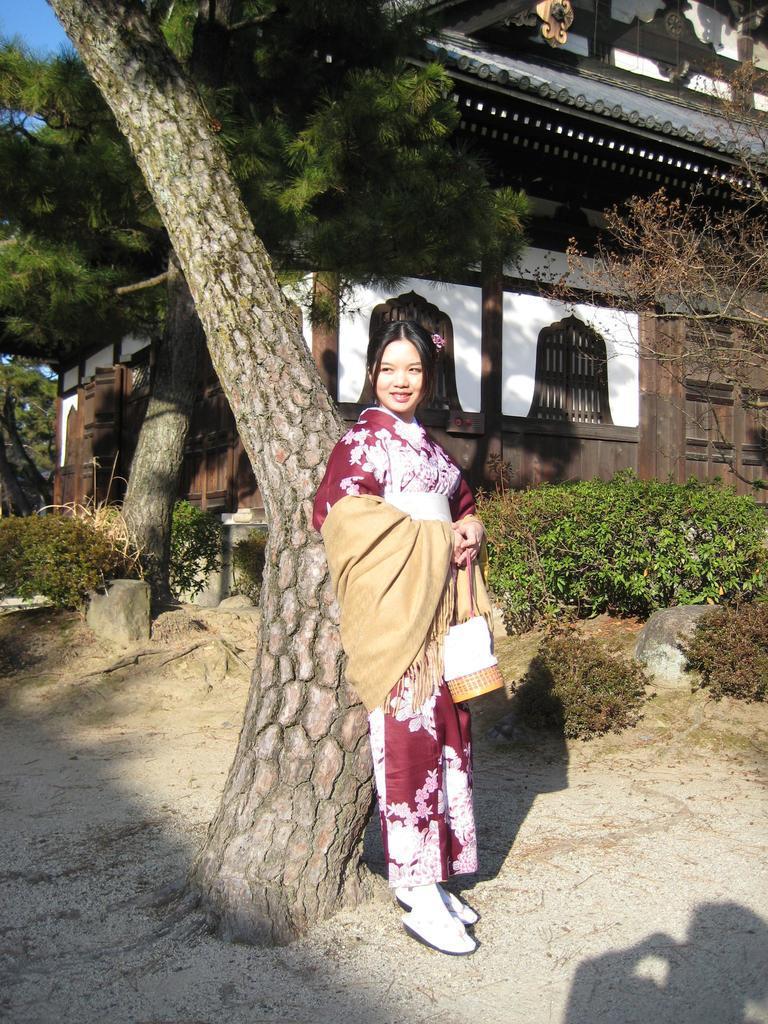In one or two sentences, can you explain what this image depicts? In this image, we can see a woman standing at the tree trunk, there are some trees, we can see a house. 